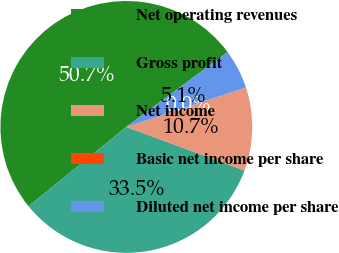Convert chart to OTSL. <chart><loc_0><loc_0><loc_500><loc_500><pie_chart><fcel>Net operating revenues<fcel>Gross profit<fcel>Net income<fcel>Basic net income per share<fcel>Diluted net income per share<nl><fcel>50.71%<fcel>33.52%<fcel>10.69%<fcel>0.0%<fcel>5.07%<nl></chart> 